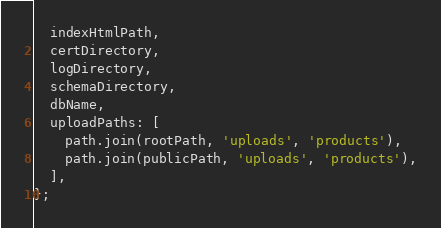<code> <loc_0><loc_0><loc_500><loc_500><_JavaScript_>  indexHtmlPath,
  certDirectory,
  logDirectory,
  schemaDirectory,
  dbName,
  uploadPaths: [
    path.join(rootPath, 'uploads', 'products'),
    path.join(publicPath, 'uploads', 'products'),
  ],
};
</code> 